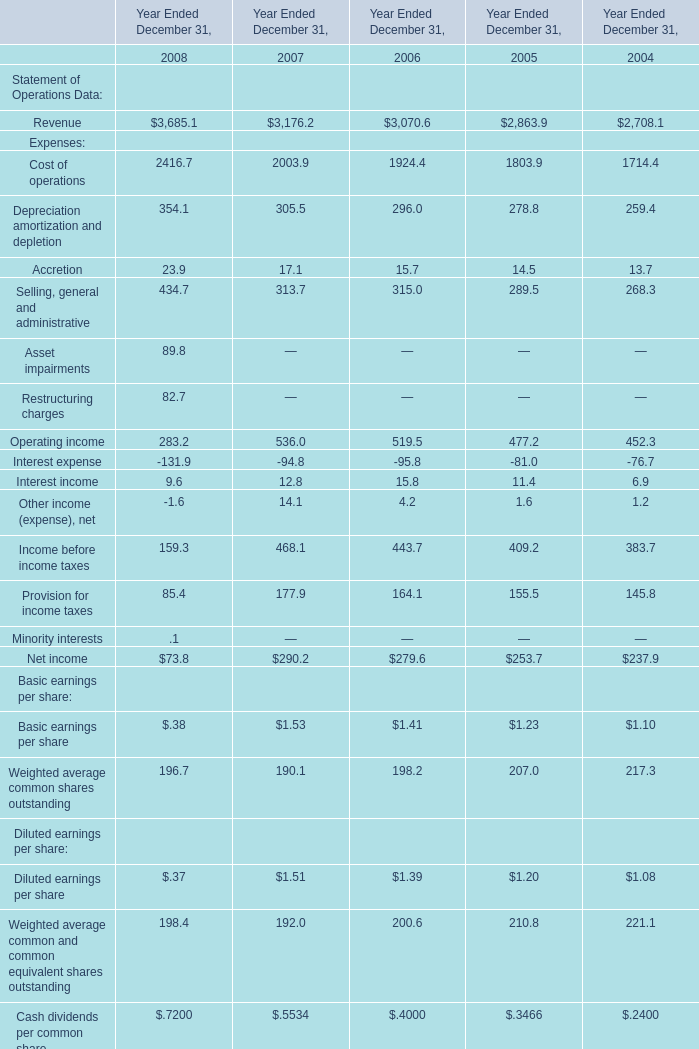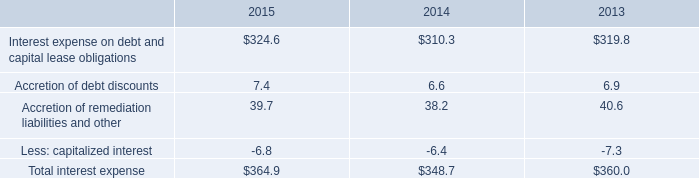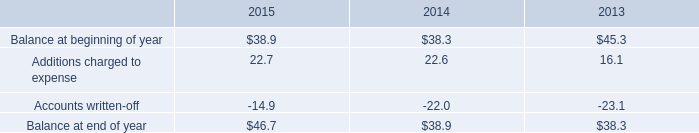What is the sum of Operating income in 2006 and Total interest expense in 2014? 
Computations: (519.5 + 348.7)
Answer: 868.2. 